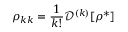<formula> <loc_0><loc_0><loc_500><loc_500>\rho _ { k k } = \frac { 1 } { k ! } \mathcal { D } ^ { ( k ) } [ \rho ^ { * } ]</formula> 